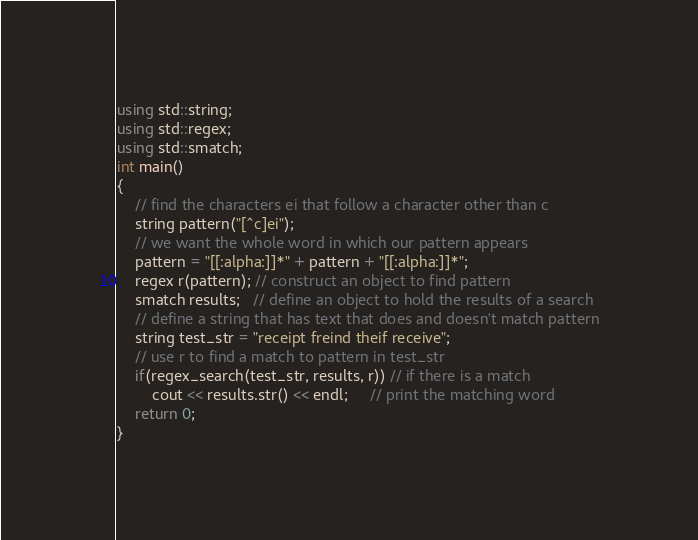<code> <loc_0><loc_0><loc_500><loc_500><_C++_>using std::string;
using std::regex;
using std::smatch;
int main()
{
    // find the characters ei that follow a character other than c
    string pattern("[^c]ei");
    // we want the whole word in which our pattern appears
    pattern = "[[:alpha:]]*" + pattern + "[[:alpha:]]*";
    regex r(pattern); // construct an object to find pattern
    smatch results;   // define an object to hold the results of a search
    // define a string that has text that does and doesn't match pattern
    string test_str = "receipt freind theif receive";
    // use r to find a match to pattern in test_str
    if(regex_search(test_str, results, r)) // if there is a match
        cout << results.str() << endl;     // print the matching word
    return 0;
}
</code> 